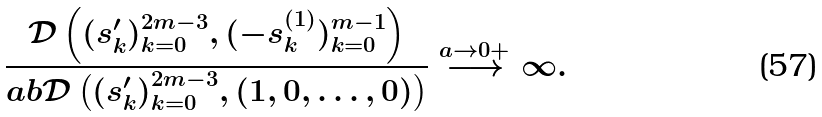<formula> <loc_0><loc_0><loc_500><loc_500>\frac { \mathcal { D } \left ( ( s _ { k } ^ { \prime } ) _ { k = 0 } ^ { 2 m - 3 } , ( - s ^ { ( 1 ) } _ { k } ) _ { k = 0 } ^ { m - 1 } \right ) } { a b \mathcal { D } \left ( ( s _ { k } ^ { \prime } ) _ { k = 0 } ^ { 2 m - 3 } , ( 1 , 0 , \dots , 0 ) \right ) } \stackrel { a \to 0 + } { \longrightarrow } \infty .</formula> 